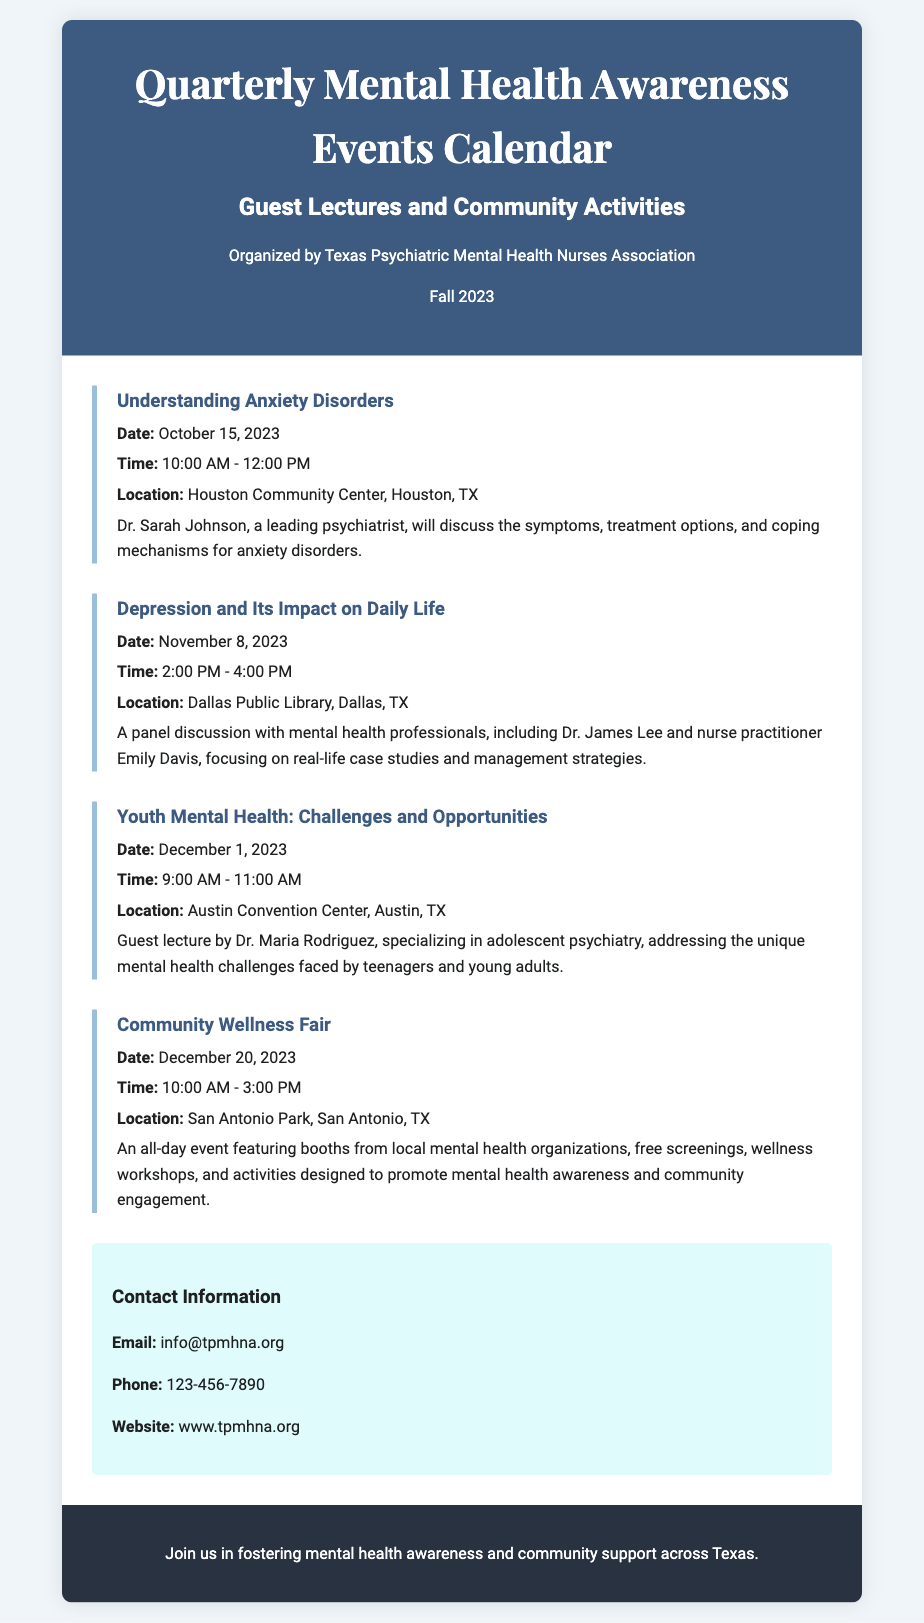What is the title of the event on October 15, 2023? The title of the event is the name of the scheduled activity on that date, which is "Understanding Anxiety Disorders."
Answer: Understanding Anxiety Disorders Who is the guest lecturer for the event on December 1, 2023? The guest lecturer is the expert invited to speak at the event on that date, which is Dr. Maria Rodriguez.
Answer: Dr. Maria Rodriguez What is the time for the Depression and Its Impact on Daily Life event? The time for that event is specified in the document, which is from 2:00 PM to 4:00 PM.
Answer: 2:00 PM - 4:00 PM Which location is hosting the Community Wellness Fair? The hosting location for the Community Wellness Fair is detailed in the document, which is San Antonio Park.
Answer: San Antonio Park What organization is responsible for organizing the events? The organization behind the event organization is stated clearly in the document, which is the Texas Psychiatric Mental Health Nurses Association.
Answer: Texas Psychiatric Mental Health Nurses Association How many community activities are listed in the document? The number of community activities can be counted from the events listed, which totals four distinct activities.
Answer: Four What type of event is scheduled on December 20, 2023? The type of the event is described in the document, specifically it is labeled as a “Community Wellness Fair.”
Answer: Community Wellness Fair What is the main topic discussed during the event on November 8, 2023? The main topic for that event is mentioned clearly in the description, which is "Depression and Its Impact on Daily Life."
Answer: Depression and Its Impact on Daily Life 